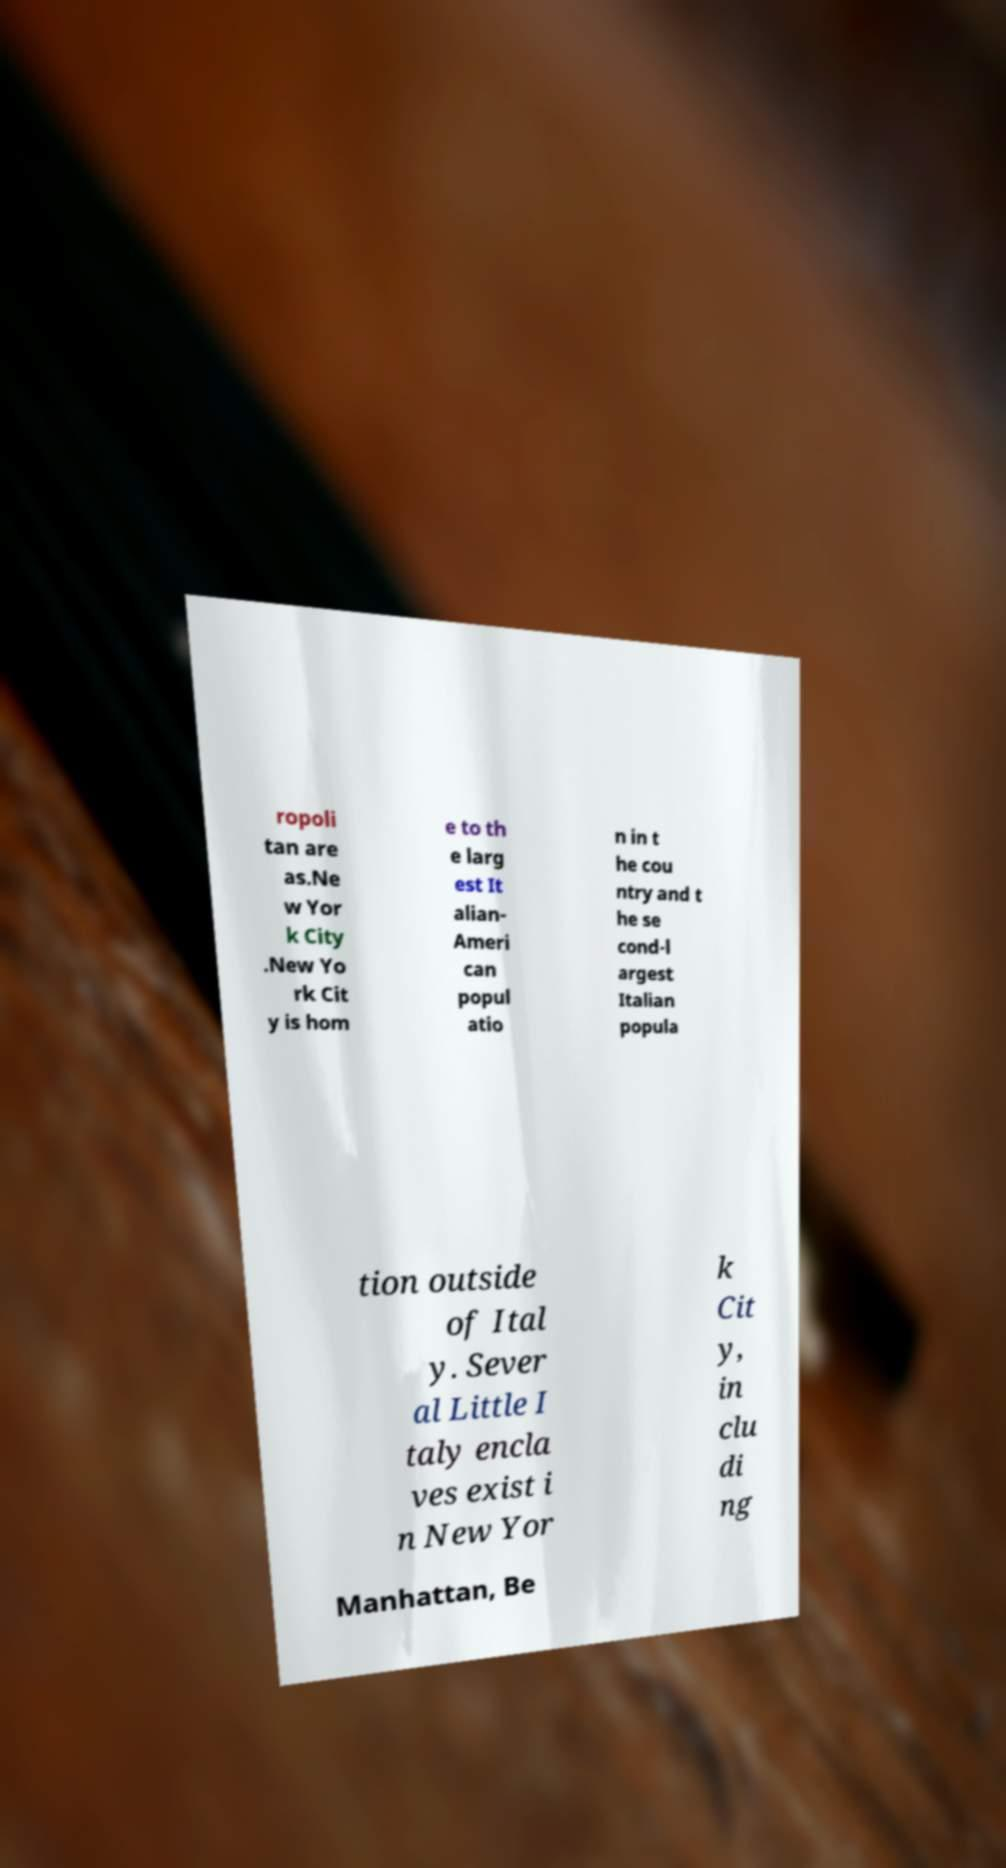For documentation purposes, I need the text within this image transcribed. Could you provide that? ropoli tan are as.Ne w Yor k City .New Yo rk Cit y is hom e to th e larg est It alian- Ameri can popul atio n in t he cou ntry and t he se cond-l argest Italian popula tion outside of Ital y. Sever al Little I taly encla ves exist i n New Yor k Cit y, in clu di ng Manhattan, Be 